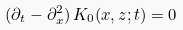Convert formula to latex. <formula><loc_0><loc_0><loc_500><loc_500>( \partial _ { t } - \partial ^ { 2 } _ { x } ) \, K _ { 0 } ( x , z ; t ) = 0</formula> 